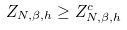Convert formula to latex. <formula><loc_0><loc_0><loc_500><loc_500>Z _ { N , \beta , h } \geq Z _ { N , \beta , h } ^ { c }</formula> 